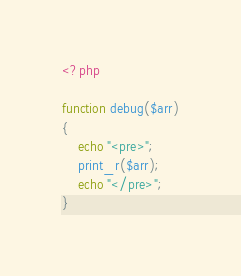Convert code to text. <code><loc_0><loc_0><loc_500><loc_500><_PHP_><?php

function debug($arr)
{
    echo "<pre>";
    print_r($arr);
    echo "</pre>";
}</code> 